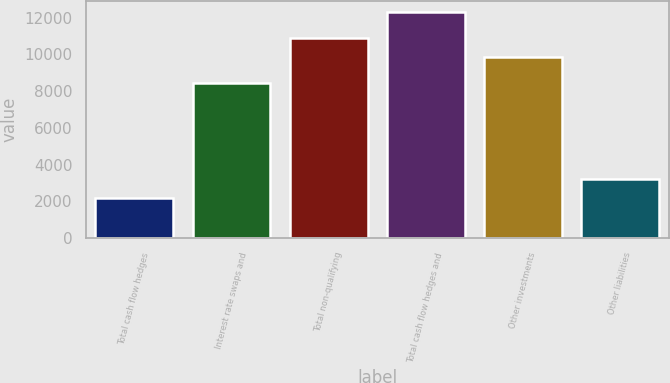<chart> <loc_0><loc_0><loc_500><loc_500><bar_chart><fcel>Total cash flow hedges<fcel>Interest rate swaps and<fcel>Total non-qualifying<fcel>Total cash flow hedges and<fcel>Other investments<fcel>Other liabilities<nl><fcel>2193<fcel>8451<fcel>10873.8<fcel>12291<fcel>9864<fcel>3202.8<nl></chart> 